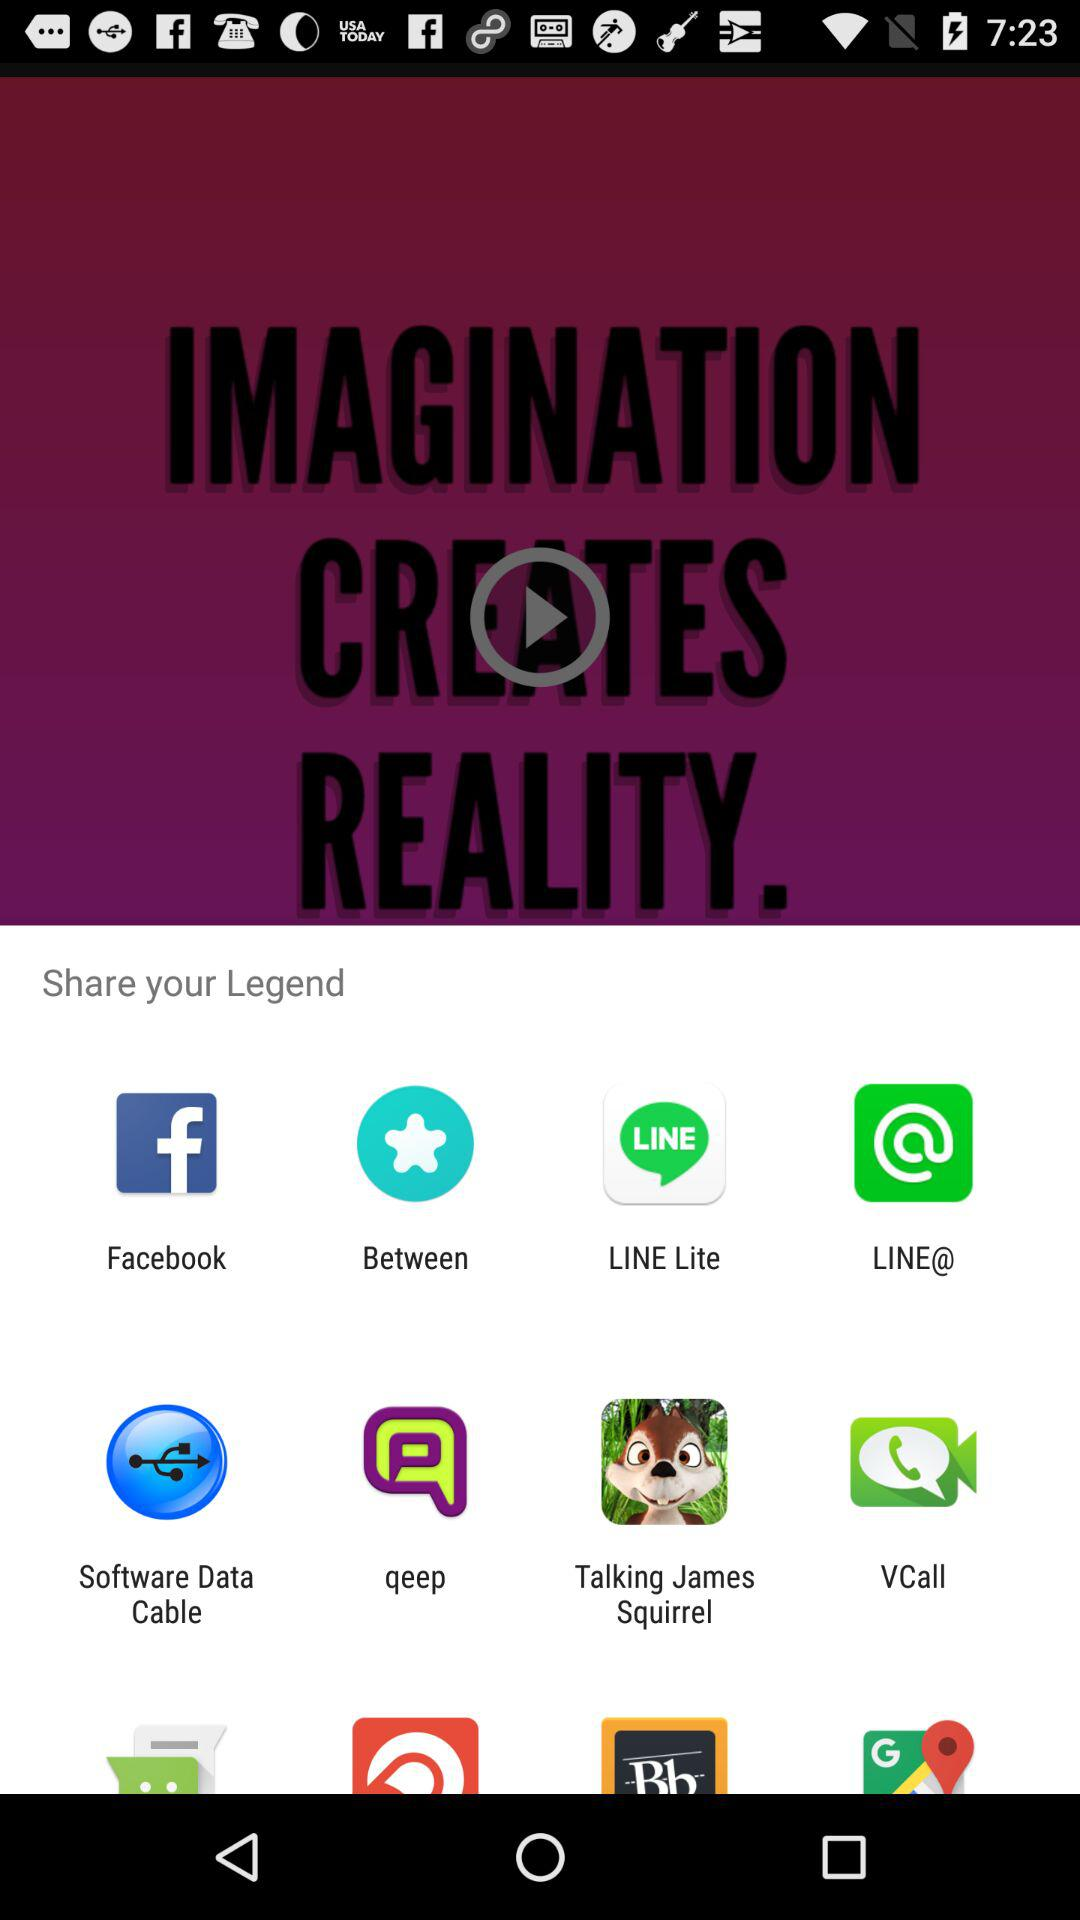Which app can I use for sharing? You can use "Facebook", "Between", "LINE Lite", "LINE@", "Software Data Cable", "qeep", "Talking James Squirrel" and "VCall" for sharing. 